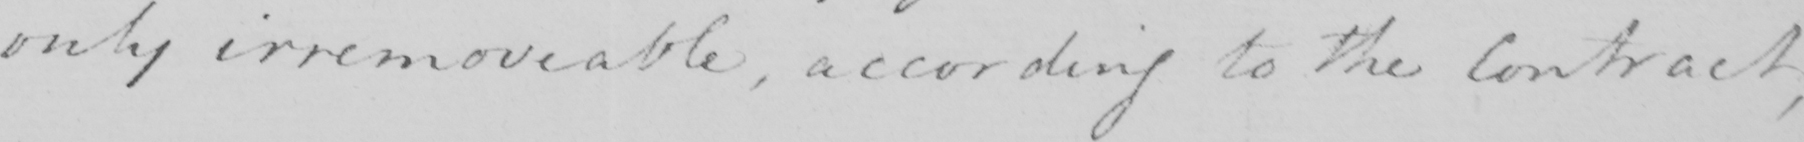What does this handwritten line say? only irremoveable , according to the Contract , 